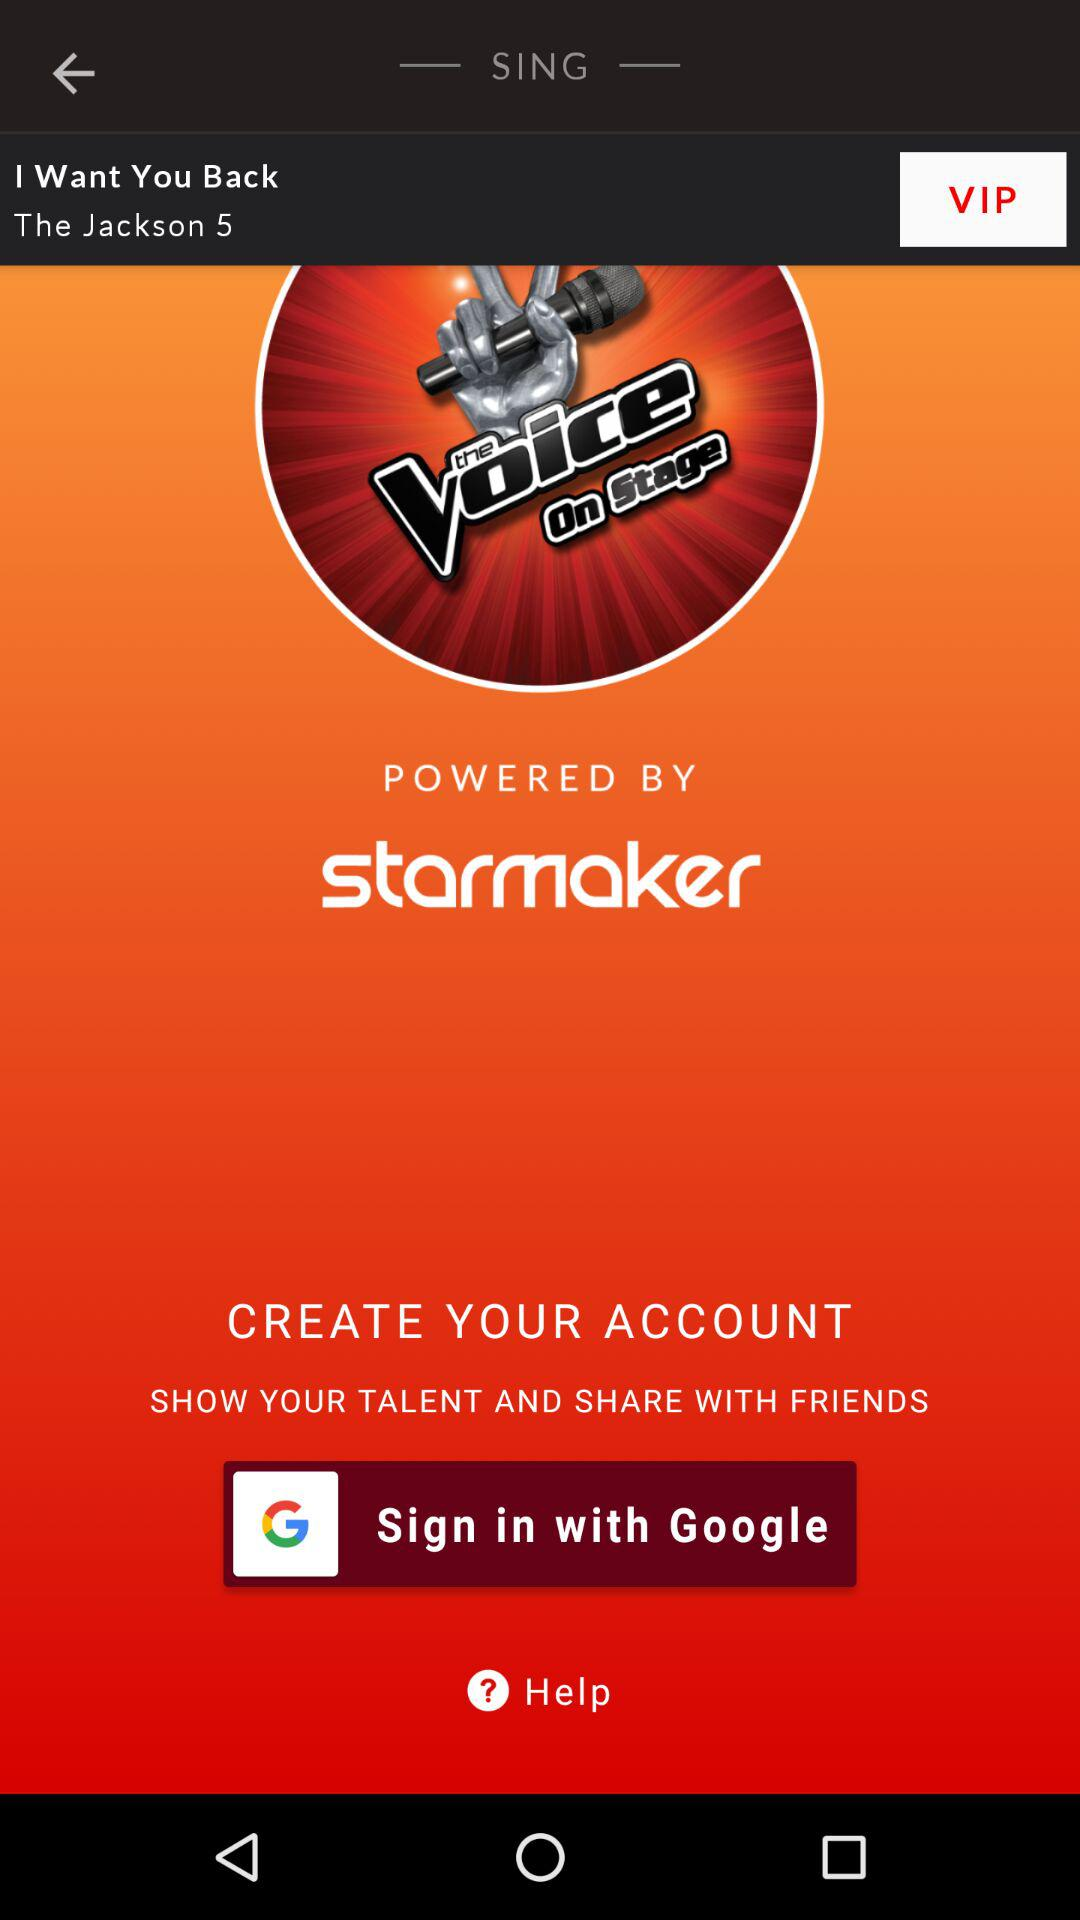What are the different options through which we can sign in? The option is "Google". 